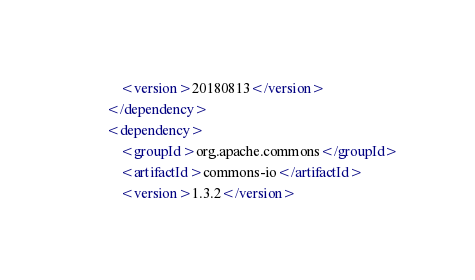Convert code to text. <code><loc_0><loc_0><loc_500><loc_500><_XML_>            <version>20180813</version>
        </dependency>
        <dependency>
            <groupId>org.apache.commons</groupId>
            <artifactId>commons-io</artifactId>
            <version>1.3.2</version></code> 